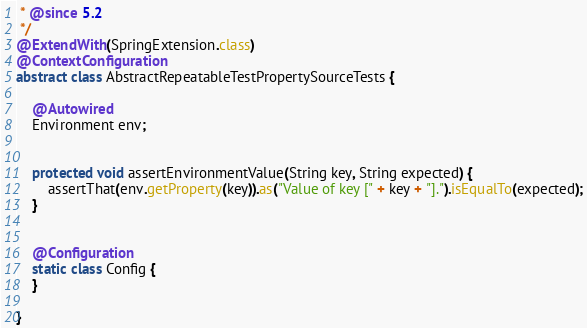Convert code to text. <code><loc_0><loc_0><loc_500><loc_500><_Java_> * @since 5.2
 */
@ExtendWith(SpringExtension.class)
@ContextConfiguration
abstract class AbstractRepeatableTestPropertySourceTests {

	@Autowired
	Environment env;


	protected void assertEnvironmentValue(String key, String expected) {
		assertThat(env.getProperty(key)).as("Value of key [" + key + "].").isEqualTo(expected);
	}


	@Configuration
	static class Config {
	}

}
</code> 